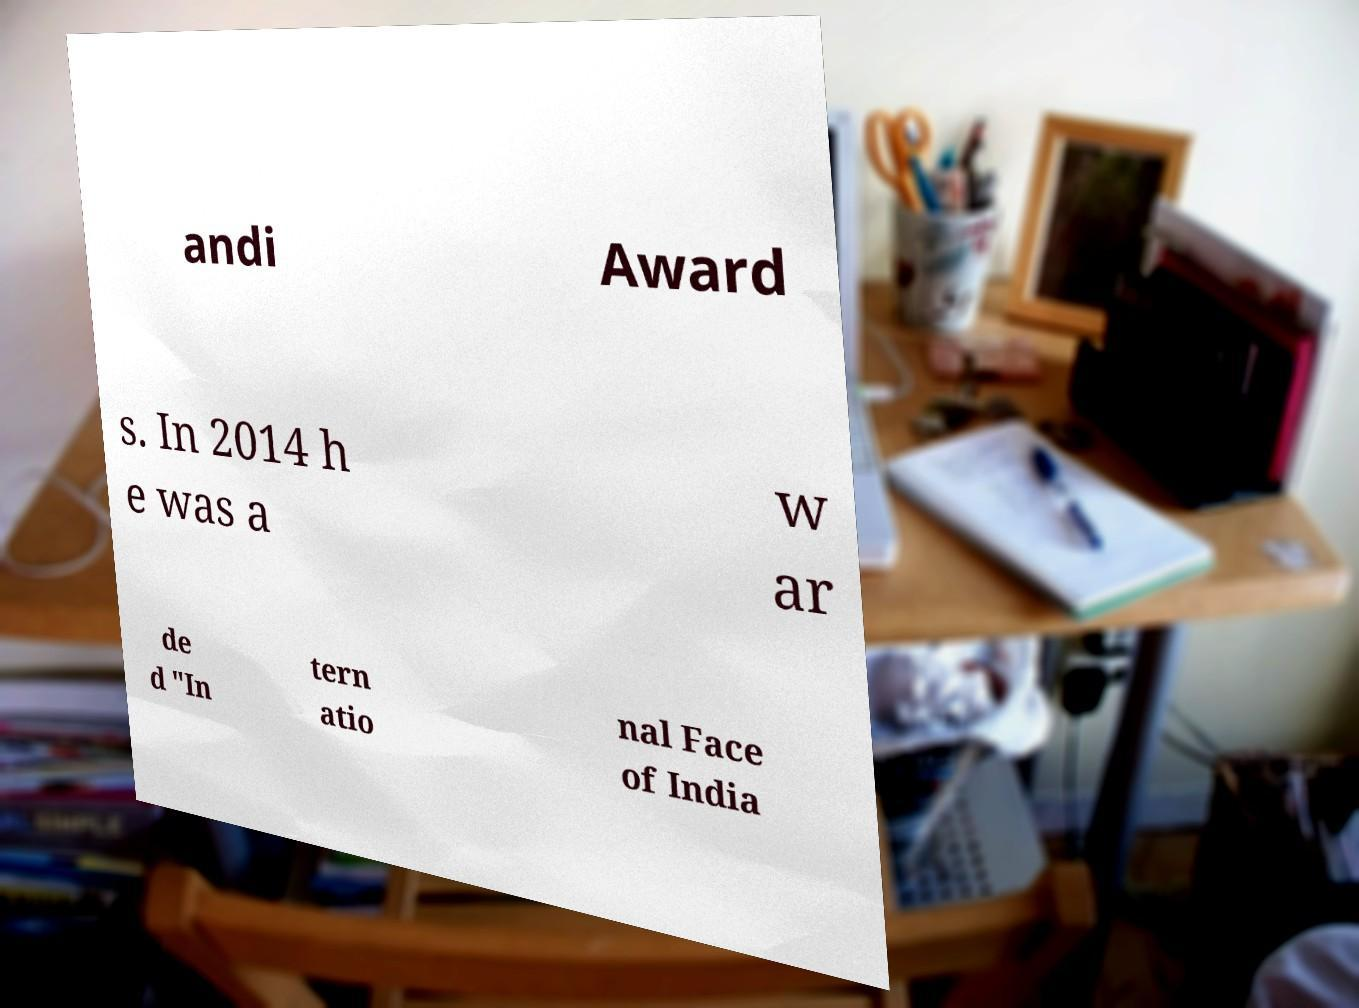Can you read and provide the text displayed in the image?This photo seems to have some interesting text. Can you extract and type it out for me? andi Award s. In 2014 h e was a w ar de d "In tern atio nal Face of India 